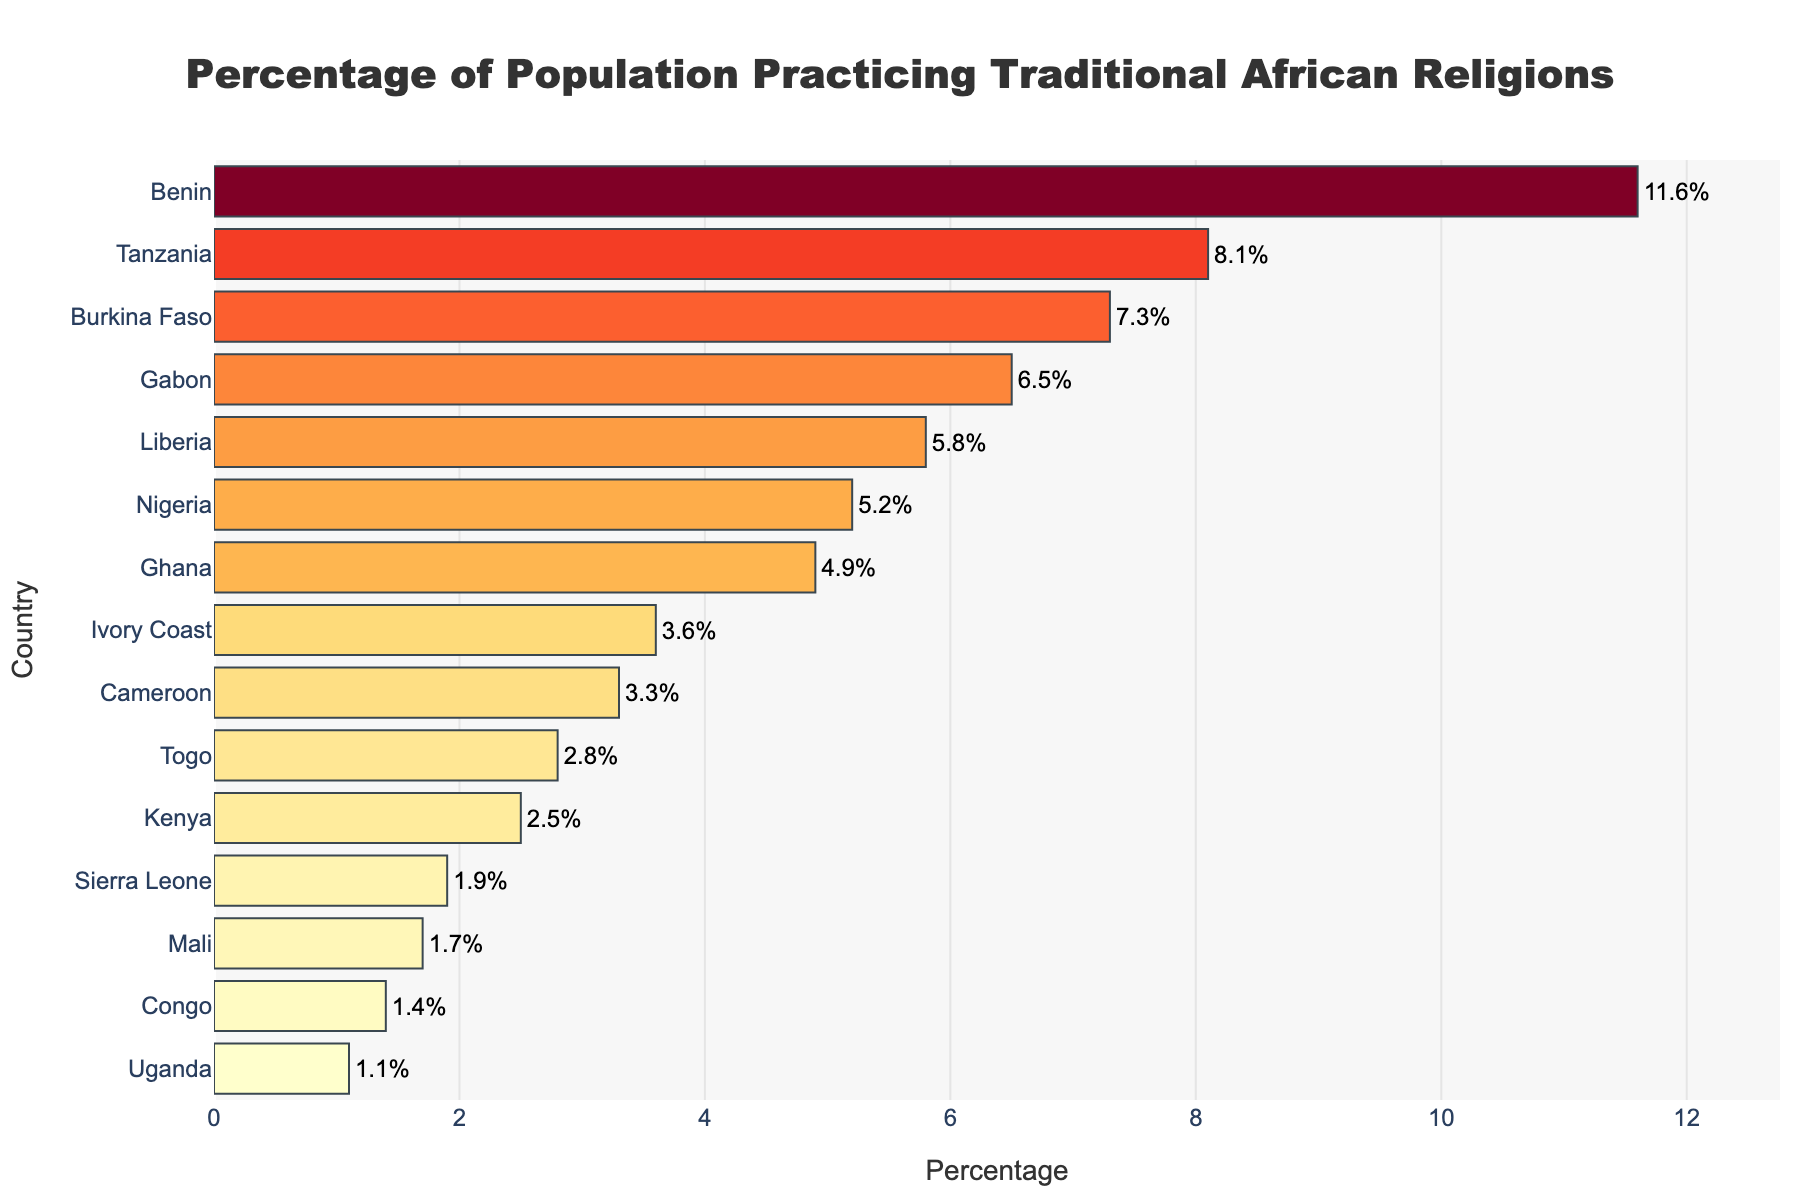What's the title of the plot? The title of the plot can be found at the top-center of the figure.
Answer: Percentage of Population Practicing Traditional African Religions Which country has the highest percentage of population practicing traditional African religions? The country with the highest bar in the plot indicates the maximum percentage.
Answer: Benin What is the percentage of population practicing traditional African religions in Kenya? Look for the bar labeled "Kenya" on the y-axis and read the corresponding value on the x-axis.
Answer: 2.5% How many countries have a percentage higher than 5%? Count all the bars that extend beyond the 5% mark on the x-axis.
Answer: 7 Which country has the lowest percentage of population practicing traditional African religions? The country with the shortest bar in the plot indicates the minimum percentage.
Answer: Uganda What is the average percentage of population practicing traditional African religions across all countries? Sum all the percentages from the list and divide by the number of countries (15).
Answer: 4.63% How does the percentage of populations practicing traditional African religions in Nigeria compare to Ghana? Compare the lengths of the bars for Nigeria and Ghana.
Answer: Nigeria is slightly higher Which countries have more than 7% of their population practicing traditional African religions? Identify the countries where the bar exceeds the 7% mark on the x-axis.
Answer: Benin, Burkina Faso, Tanzania 